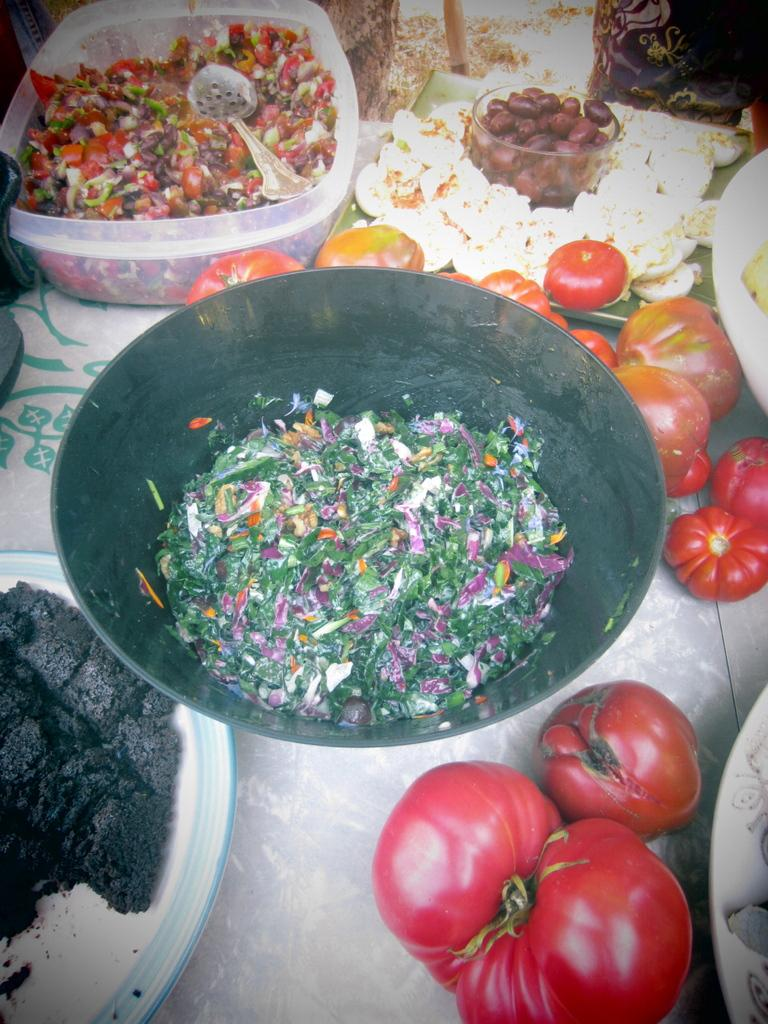What type of food can be seen in the image? There are tomatoes in the image. What other types of food or eatables are present in the image? There are other eatables in the image besides the tomatoes. Where are the tomatoes and eatables located in the image? The tomatoes and eatables are placed on a table. What type of punishment is being given to the tomato plant in the image? There is no tomato plant present in the image, and therefore no punishment is being given. 